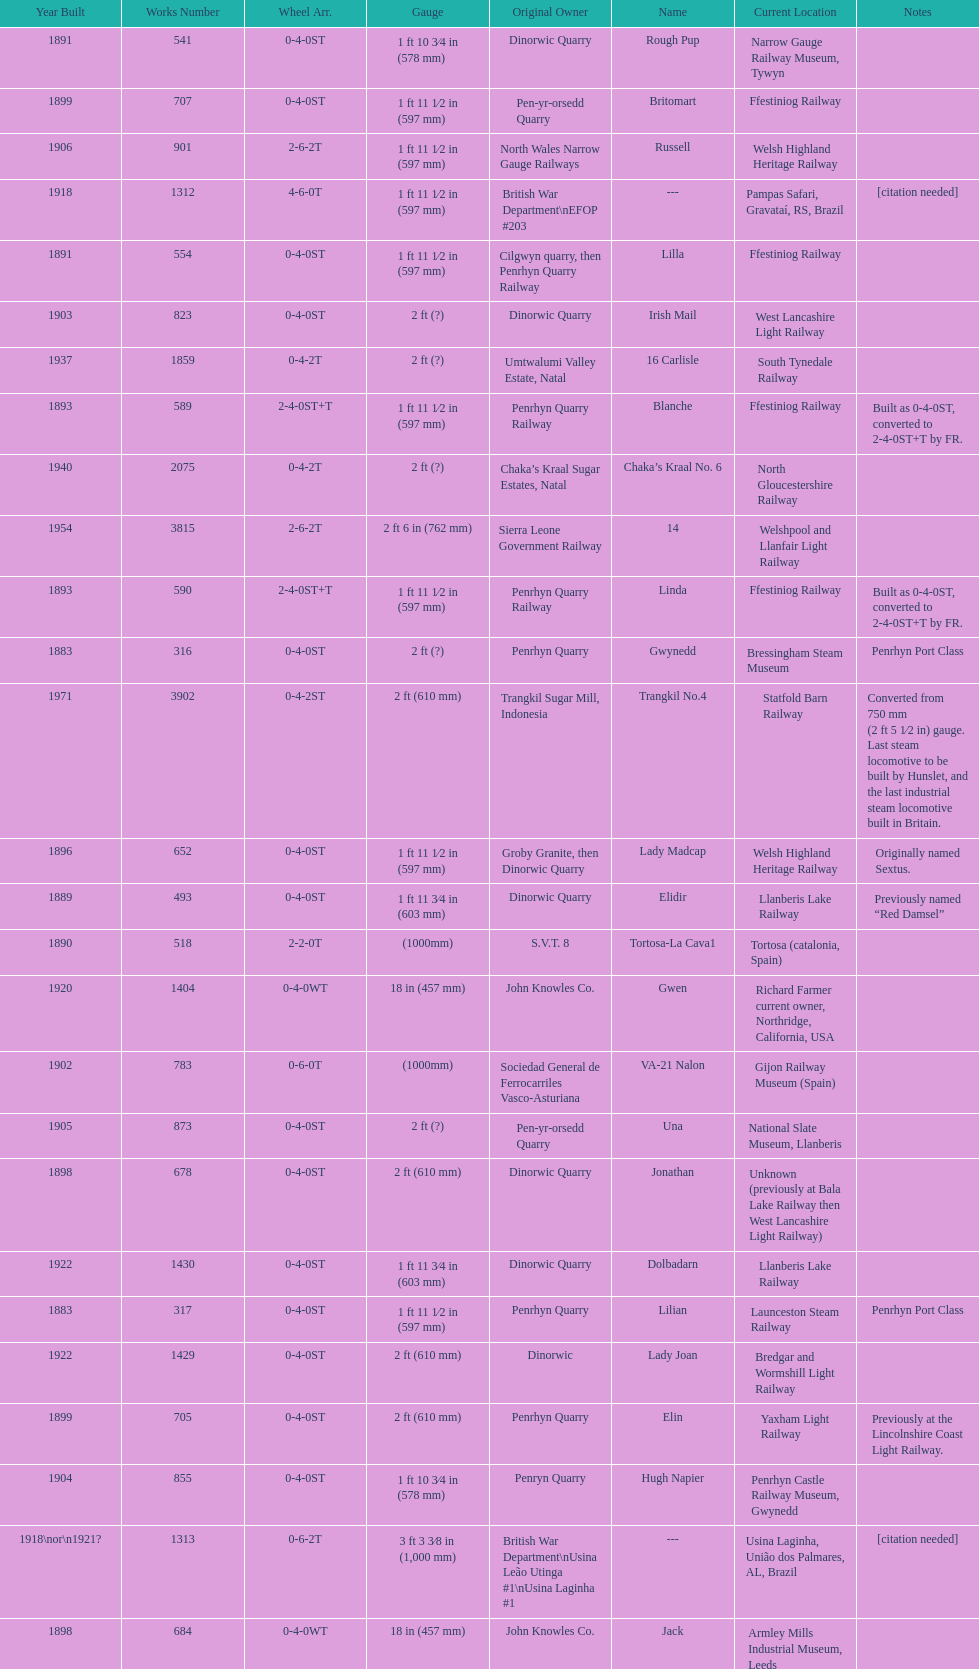What is the name of the last locomotive to be located at the bressingham steam museum? Gwynedd. 